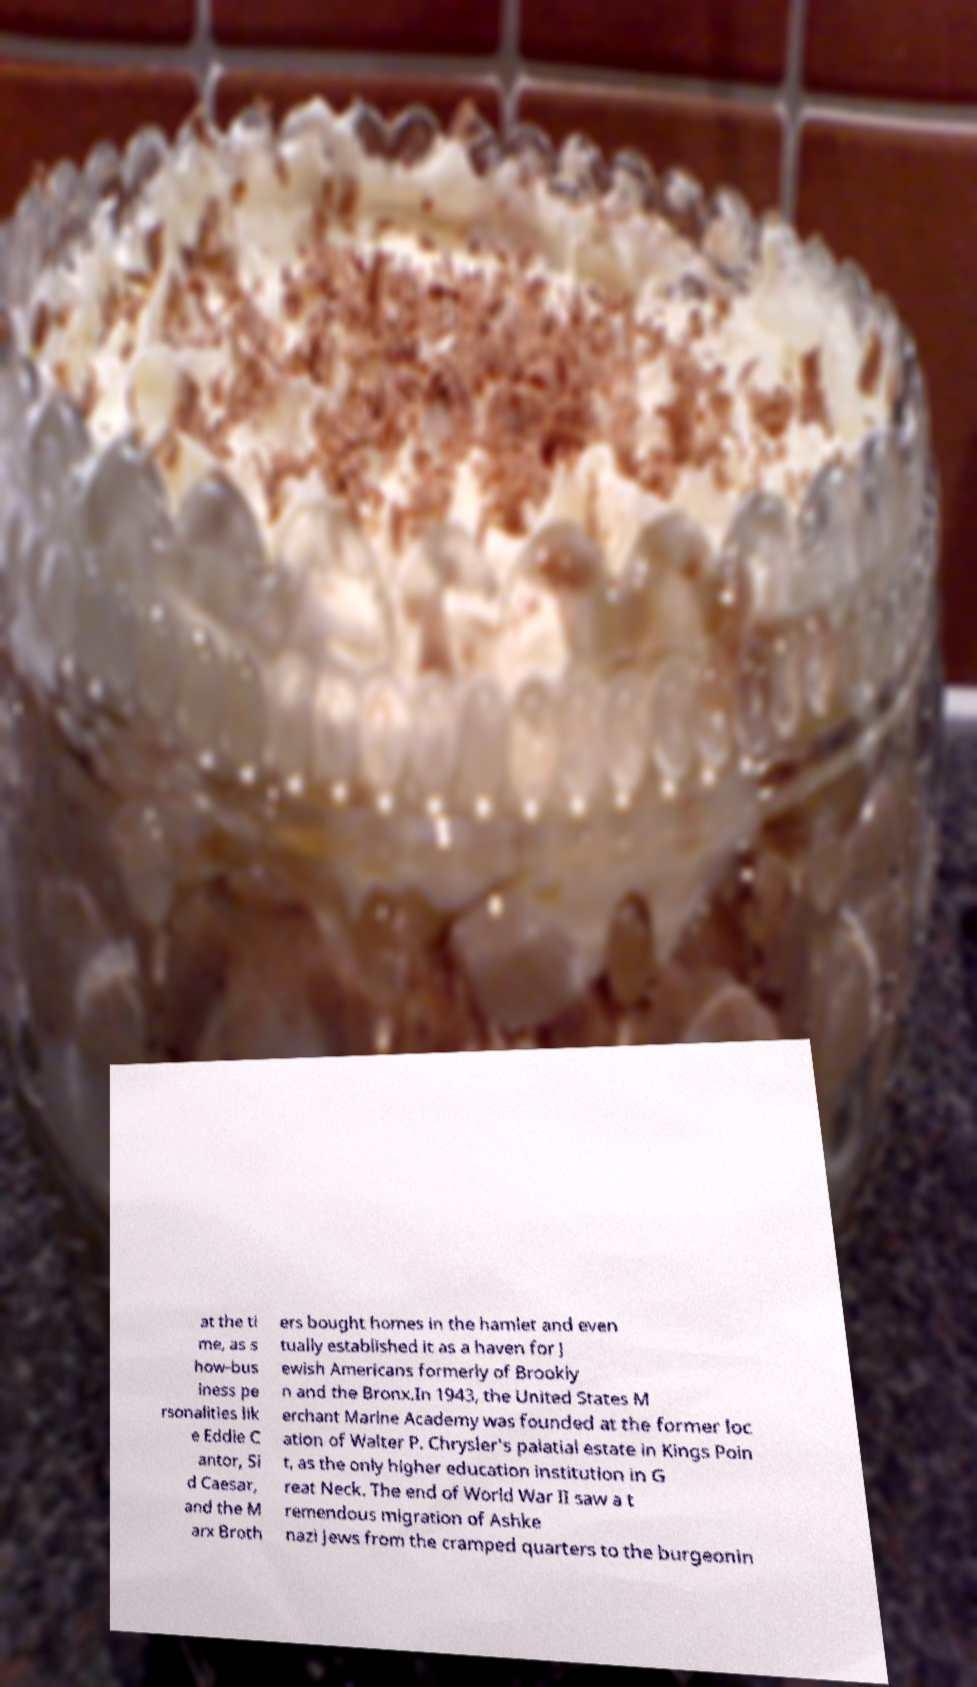For documentation purposes, I need the text within this image transcribed. Could you provide that? at the ti me, as s how-bus iness pe rsonalities lik e Eddie C antor, Si d Caesar, and the M arx Broth ers bought homes in the hamlet and even tually established it as a haven for J ewish Americans formerly of Brookly n and the Bronx.In 1943, the United States M erchant Marine Academy was founded at the former loc ation of Walter P. Chrysler's palatial estate in Kings Poin t, as the only higher education institution in G reat Neck. The end of World War II saw a t remendous migration of Ashke nazi Jews from the cramped quarters to the burgeonin 